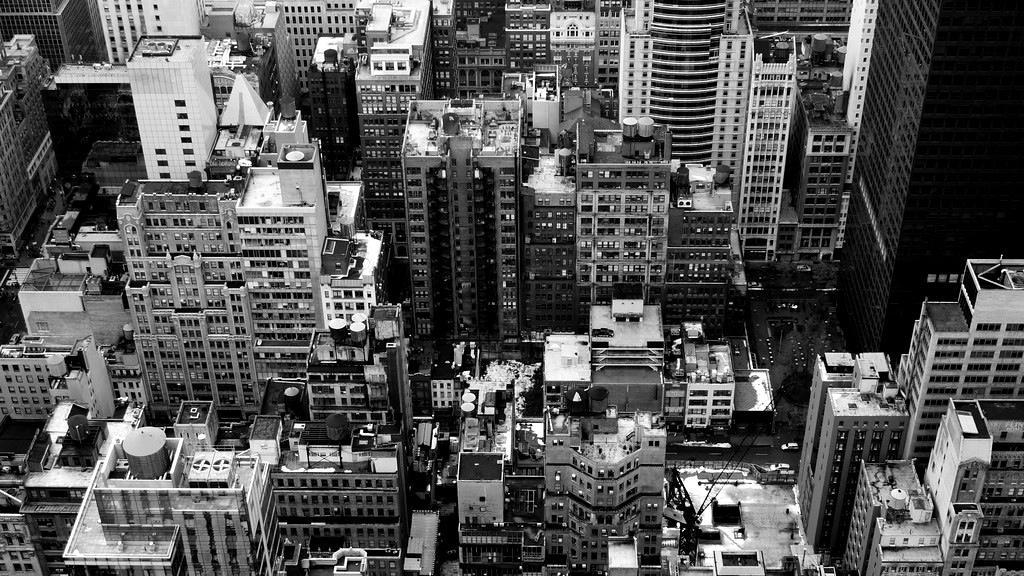What is the main subject of the image? The main subject of the image is a group of buildings. Can you describe the buildings in the image? Unfortunately, the provided facts do not give any specific details about the buildings. Are there any other objects or structures visible in the image? The facts only mention a group of buildings, so there is no information about any other objects or structures. How many women are present in the image? There is no mention of women or any other people in the image, so it is not possible to answer this question. 